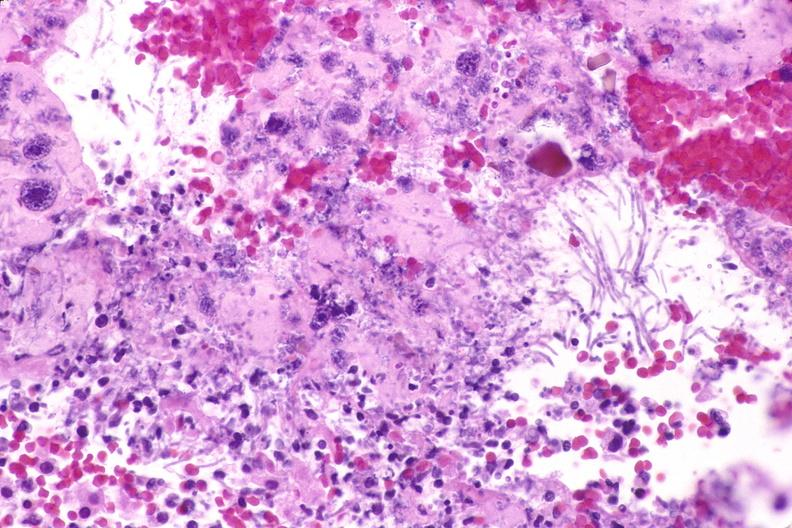does cm show esohagus, candida?
Answer the question using a single word or phrase. No 